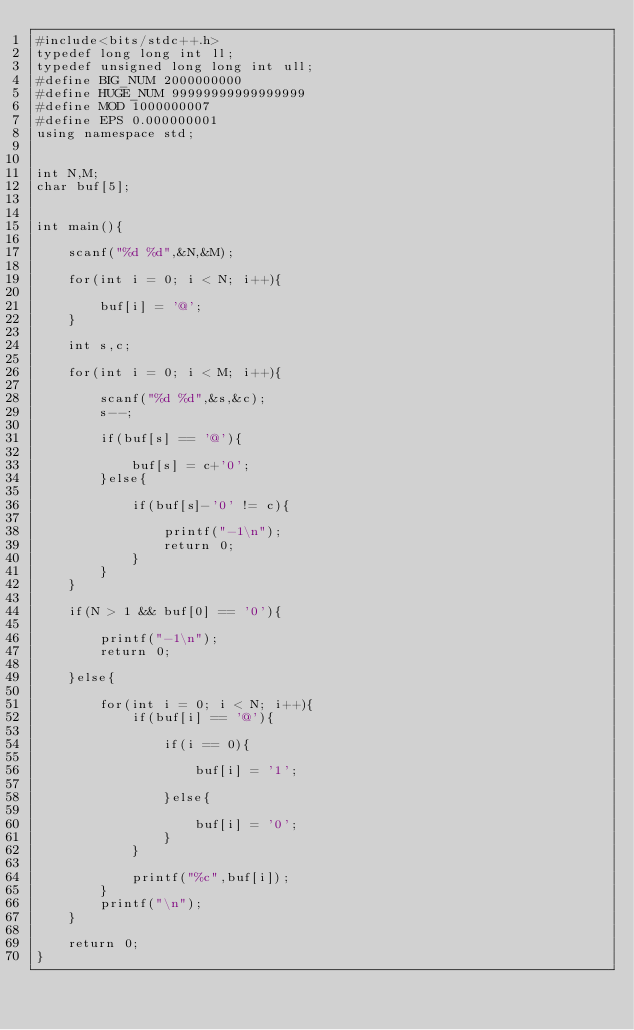<code> <loc_0><loc_0><loc_500><loc_500><_C++_>#include<bits/stdc++.h>
typedef long long int ll;
typedef unsigned long long int ull;
#define BIG_NUM 2000000000
#define HUGE_NUM 99999999999999999
#define MOD 1000000007
#define EPS 0.000000001
using namespace std;


int N,M;
char buf[5];


int main(){

	scanf("%d %d",&N,&M);

	for(int i = 0; i < N; i++){

		buf[i] = '@';
	}

	int s,c;

	for(int i = 0; i < M; i++){

		scanf("%d %d",&s,&c);
		s--;

		if(buf[s] == '@'){

			buf[s] = c+'0';
		}else{

			if(buf[s]-'0' != c){

				printf("-1\n");
				return 0;
			}
		}
	}

	if(N > 1 && buf[0] == '0'){

		printf("-1\n");
		return 0;

	}else{

		for(int i = 0; i < N; i++){
			if(buf[i] == '@'){

				if(i == 0){

					buf[i] = '1';

				}else{

					buf[i] = '0';
				}
			}

			printf("%c",buf[i]);
		}
		printf("\n");
	}

	return 0;
}
</code> 